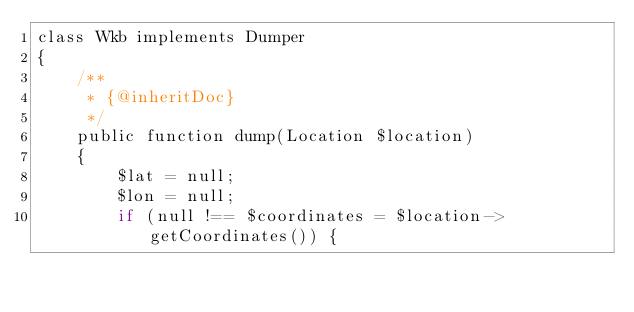Convert code to text. <code><loc_0><loc_0><loc_500><loc_500><_PHP_>class Wkb implements Dumper
{
    /**
     * {@inheritDoc}
     */
    public function dump(Location $location)
    {
        $lat = null;
        $lon = null;
        if (null !== $coordinates = $location->getCoordinates()) {</code> 